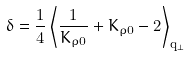Convert formula to latex. <formula><loc_0><loc_0><loc_500><loc_500>\delta = \frac { 1 } { 4 } \left \langle \frac { 1 } { K _ { \rho 0 } } + K _ { \rho 0 } - 2 \right \rangle _ { { \mathbf q } _ { \perp } }</formula> 